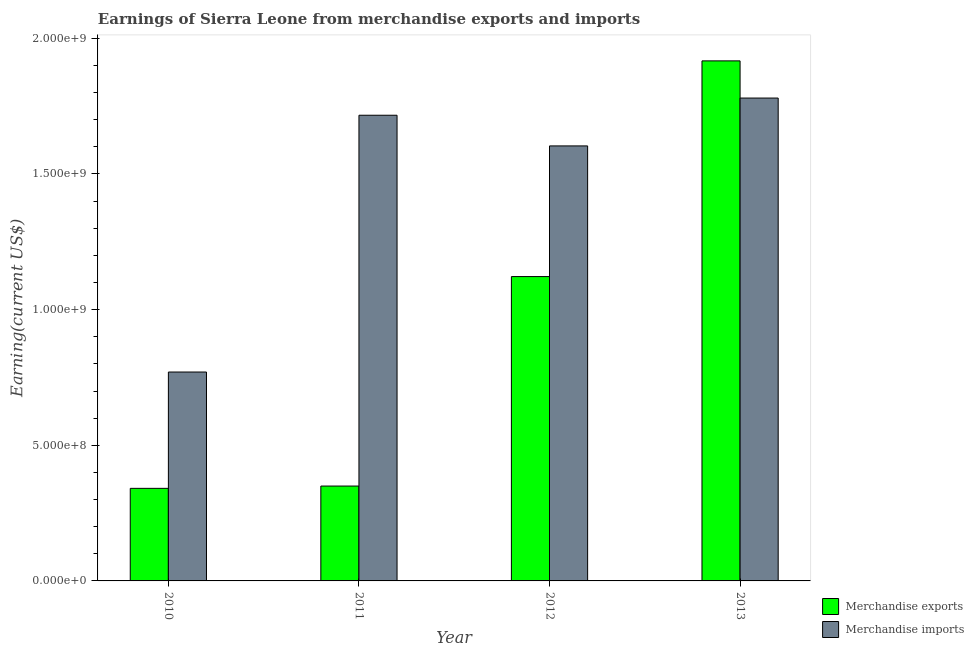How many different coloured bars are there?
Provide a succinct answer. 2. Are the number of bars per tick equal to the number of legend labels?
Ensure brevity in your answer.  Yes. How many bars are there on the 3rd tick from the left?
Provide a succinct answer. 2. How many bars are there on the 1st tick from the right?
Provide a succinct answer. 2. What is the label of the 2nd group of bars from the left?
Provide a succinct answer. 2011. In how many cases, is the number of bars for a given year not equal to the number of legend labels?
Provide a succinct answer. 0. What is the earnings from merchandise imports in 2012?
Your answer should be very brief. 1.60e+09. Across all years, what is the maximum earnings from merchandise imports?
Keep it short and to the point. 1.78e+09. Across all years, what is the minimum earnings from merchandise imports?
Make the answer very short. 7.70e+08. In which year was the earnings from merchandise exports maximum?
Your answer should be very brief. 2013. In which year was the earnings from merchandise exports minimum?
Keep it short and to the point. 2010. What is the total earnings from merchandise exports in the graph?
Provide a short and direct response. 3.73e+09. What is the difference between the earnings from merchandise exports in 2011 and that in 2012?
Make the answer very short. -7.72e+08. What is the difference between the earnings from merchandise imports in 2013 and the earnings from merchandise exports in 2011?
Offer a very short reply. 6.34e+07. What is the average earnings from merchandise exports per year?
Offer a very short reply. 9.32e+08. In the year 2012, what is the difference between the earnings from merchandise imports and earnings from merchandise exports?
Your response must be concise. 0. What is the ratio of the earnings from merchandise exports in 2011 to that in 2012?
Offer a terse response. 0.31. What is the difference between the highest and the second highest earnings from merchandise imports?
Provide a short and direct response. 6.34e+07. What is the difference between the highest and the lowest earnings from merchandise imports?
Your answer should be very brief. 1.01e+09. What does the 1st bar from the right in 2013 represents?
Your response must be concise. Merchandise imports. How many bars are there?
Provide a succinct answer. 8. How many years are there in the graph?
Keep it short and to the point. 4. What is the difference between two consecutive major ticks on the Y-axis?
Provide a short and direct response. 5.00e+08. Does the graph contain any zero values?
Give a very brief answer. No. Where does the legend appear in the graph?
Provide a short and direct response. Bottom right. What is the title of the graph?
Provide a succinct answer. Earnings of Sierra Leone from merchandise exports and imports. What is the label or title of the X-axis?
Provide a succinct answer. Year. What is the label or title of the Y-axis?
Your answer should be compact. Earning(current US$). What is the Earning(current US$) of Merchandise exports in 2010?
Offer a very short reply. 3.41e+08. What is the Earning(current US$) of Merchandise imports in 2010?
Keep it short and to the point. 7.70e+08. What is the Earning(current US$) in Merchandise exports in 2011?
Make the answer very short. 3.50e+08. What is the Earning(current US$) in Merchandise imports in 2011?
Your answer should be very brief. 1.72e+09. What is the Earning(current US$) of Merchandise exports in 2012?
Provide a short and direct response. 1.12e+09. What is the Earning(current US$) of Merchandise imports in 2012?
Make the answer very short. 1.60e+09. What is the Earning(current US$) of Merchandise exports in 2013?
Make the answer very short. 1.92e+09. What is the Earning(current US$) in Merchandise imports in 2013?
Provide a succinct answer. 1.78e+09. Across all years, what is the maximum Earning(current US$) in Merchandise exports?
Make the answer very short. 1.92e+09. Across all years, what is the maximum Earning(current US$) of Merchandise imports?
Your answer should be compact. 1.78e+09. Across all years, what is the minimum Earning(current US$) of Merchandise exports?
Your answer should be compact. 3.41e+08. Across all years, what is the minimum Earning(current US$) in Merchandise imports?
Give a very brief answer. 7.70e+08. What is the total Earning(current US$) in Merchandise exports in the graph?
Your response must be concise. 3.73e+09. What is the total Earning(current US$) of Merchandise imports in the graph?
Keep it short and to the point. 5.87e+09. What is the difference between the Earning(current US$) of Merchandise exports in 2010 and that in 2011?
Your answer should be compact. -8.48e+06. What is the difference between the Earning(current US$) of Merchandise imports in 2010 and that in 2011?
Your answer should be very brief. -9.47e+08. What is the difference between the Earning(current US$) of Merchandise exports in 2010 and that in 2012?
Your answer should be compact. -7.81e+08. What is the difference between the Earning(current US$) of Merchandise imports in 2010 and that in 2012?
Give a very brief answer. -8.33e+08. What is the difference between the Earning(current US$) of Merchandise exports in 2010 and that in 2013?
Provide a succinct answer. -1.58e+09. What is the difference between the Earning(current US$) in Merchandise imports in 2010 and that in 2013?
Keep it short and to the point. -1.01e+09. What is the difference between the Earning(current US$) in Merchandise exports in 2011 and that in 2012?
Offer a terse response. -7.72e+08. What is the difference between the Earning(current US$) in Merchandise imports in 2011 and that in 2012?
Offer a very short reply. 1.13e+08. What is the difference between the Earning(current US$) of Merchandise exports in 2011 and that in 2013?
Offer a very short reply. -1.57e+09. What is the difference between the Earning(current US$) of Merchandise imports in 2011 and that in 2013?
Your response must be concise. -6.34e+07. What is the difference between the Earning(current US$) in Merchandise exports in 2012 and that in 2013?
Give a very brief answer. -7.95e+08. What is the difference between the Earning(current US$) in Merchandise imports in 2012 and that in 2013?
Your answer should be compact. -1.76e+08. What is the difference between the Earning(current US$) in Merchandise exports in 2010 and the Earning(current US$) in Merchandise imports in 2011?
Your answer should be compact. -1.38e+09. What is the difference between the Earning(current US$) in Merchandise exports in 2010 and the Earning(current US$) in Merchandise imports in 2012?
Keep it short and to the point. -1.26e+09. What is the difference between the Earning(current US$) in Merchandise exports in 2010 and the Earning(current US$) in Merchandise imports in 2013?
Keep it short and to the point. -1.44e+09. What is the difference between the Earning(current US$) in Merchandise exports in 2011 and the Earning(current US$) in Merchandise imports in 2012?
Your answer should be compact. -1.25e+09. What is the difference between the Earning(current US$) of Merchandise exports in 2011 and the Earning(current US$) of Merchandise imports in 2013?
Your response must be concise. -1.43e+09. What is the difference between the Earning(current US$) in Merchandise exports in 2012 and the Earning(current US$) in Merchandise imports in 2013?
Your response must be concise. -6.58e+08. What is the average Earning(current US$) in Merchandise exports per year?
Make the answer very short. 9.32e+08. What is the average Earning(current US$) of Merchandise imports per year?
Ensure brevity in your answer.  1.47e+09. In the year 2010, what is the difference between the Earning(current US$) of Merchandise exports and Earning(current US$) of Merchandise imports?
Ensure brevity in your answer.  -4.29e+08. In the year 2011, what is the difference between the Earning(current US$) in Merchandise exports and Earning(current US$) in Merchandise imports?
Provide a short and direct response. -1.37e+09. In the year 2012, what is the difference between the Earning(current US$) of Merchandise exports and Earning(current US$) of Merchandise imports?
Offer a terse response. -4.82e+08. In the year 2013, what is the difference between the Earning(current US$) of Merchandise exports and Earning(current US$) of Merchandise imports?
Provide a succinct answer. 1.37e+08. What is the ratio of the Earning(current US$) in Merchandise exports in 2010 to that in 2011?
Ensure brevity in your answer.  0.98. What is the ratio of the Earning(current US$) in Merchandise imports in 2010 to that in 2011?
Provide a succinct answer. 0.45. What is the ratio of the Earning(current US$) in Merchandise exports in 2010 to that in 2012?
Ensure brevity in your answer.  0.3. What is the ratio of the Earning(current US$) of Merchandise imports in 2010 to that in 2012?
Your answer should be very brief. 0.48. What is the ratio of the Earning(current US$) of Merchandise exports in 2010 to that in 2013?
Ensure brevity in your answer.  0.18. What is the ratio of the Earning(current US$) in Merchandise imports in 2010 to that in 2013?
Provide a succinct answer. 0.43. What is the ratio of the Earning(current US$) in Merchandise exports in 2011 to that in 2012?
Make the answer very short. 0.31. What is the ratio of the Earning(current US$) in Merchandise imports in 2011 to that in 2012?
Provide a short and direct response. 1.07. What is the ratio of the Earning(current US$) of Merchandise exports in 2011 to that in 2013?
Provide a short and direct response. 0.18. What is the ratio of the Earning(current US$) of Merchandise imports in 2011 to that in 2013?
Give a very brief answer. 0.96. What is the ratio of the Earning(current US$) in Merchandise exports in 2012 to that in 2013?
Your answer should be very brief. 0.59. What is the ratio of the Earning(current US$) of Merchandise imports in 2012 to that in 2013?
Your answer should be very brief. 0.9. What is the difference between the highest and the second highest Earning(current US$) in Merchandise exports?
Your answer should be compact. 7.95e+08. What is the difference between the highest and the second highest Earning(current US$) in Merchandise imports?
Make the answer very short. 6.34e+07. What is the difference between the highest and the lowest Earning(current US$) of Merchandise exports?
Provide a succinct answer. 1.58e+09. What is the difference between the highest and the lowest Earning(current US$) in Merchandise imports?
Your answer should be very brief. 1.01e+09. 